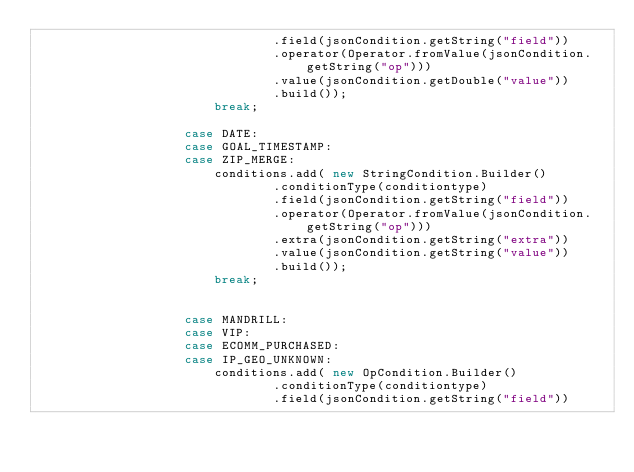Convert code to text. <code><loc_0><loc_0><loc_500><loc_500><_Java_>								.field(jsonCondition.getString("field"))
								.operator(Operator.fromValue(jsonCondition.getString("op")))
								.value(jsonCondition.getDouble("value"))
								.build());
						break;

					case DATE:
					case GOAL_TIMESTAMP:
					case ZIP_MERGE:
						conditions.add( new StringCondition.Builder()
								.conditionType(conditiontype)
								.field(jsonCondition.getString("field"))
								.operator(Operator.fromValue(jsonCondition.getString("op")))
								.extra(jsonCondition.getString("extra"))
								.value(jsonCondition.getString("value"))
								.build());
						break;


					case MANDRILL:
					case VIP:
					case ECOMM_PURCHASED:
					case IP_GEO_UNKNOWN:
						conditions.add( new OpCondition.Builder()
								.conditionType(conditiontype)
								.field(jsonCondition.getString("field"))</code> 